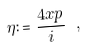Convert formula to latex. <formula><loc_0><loc_0><loc_500><loc_500>\eta \colon = \frac { 4 x p } { i } \ ,</formula> 